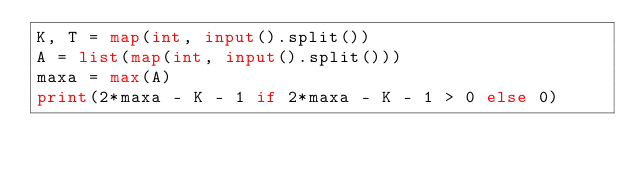<code> <loc_0><loc_0><loc_500><loc_500><_Python_>K, T = map(int, input().split())
A = list(map(int, input().split()))
maxa = max(A)
print(2*maxa - K - 1 if 2*maxa - K - 1 > 0 else 0)</code> 